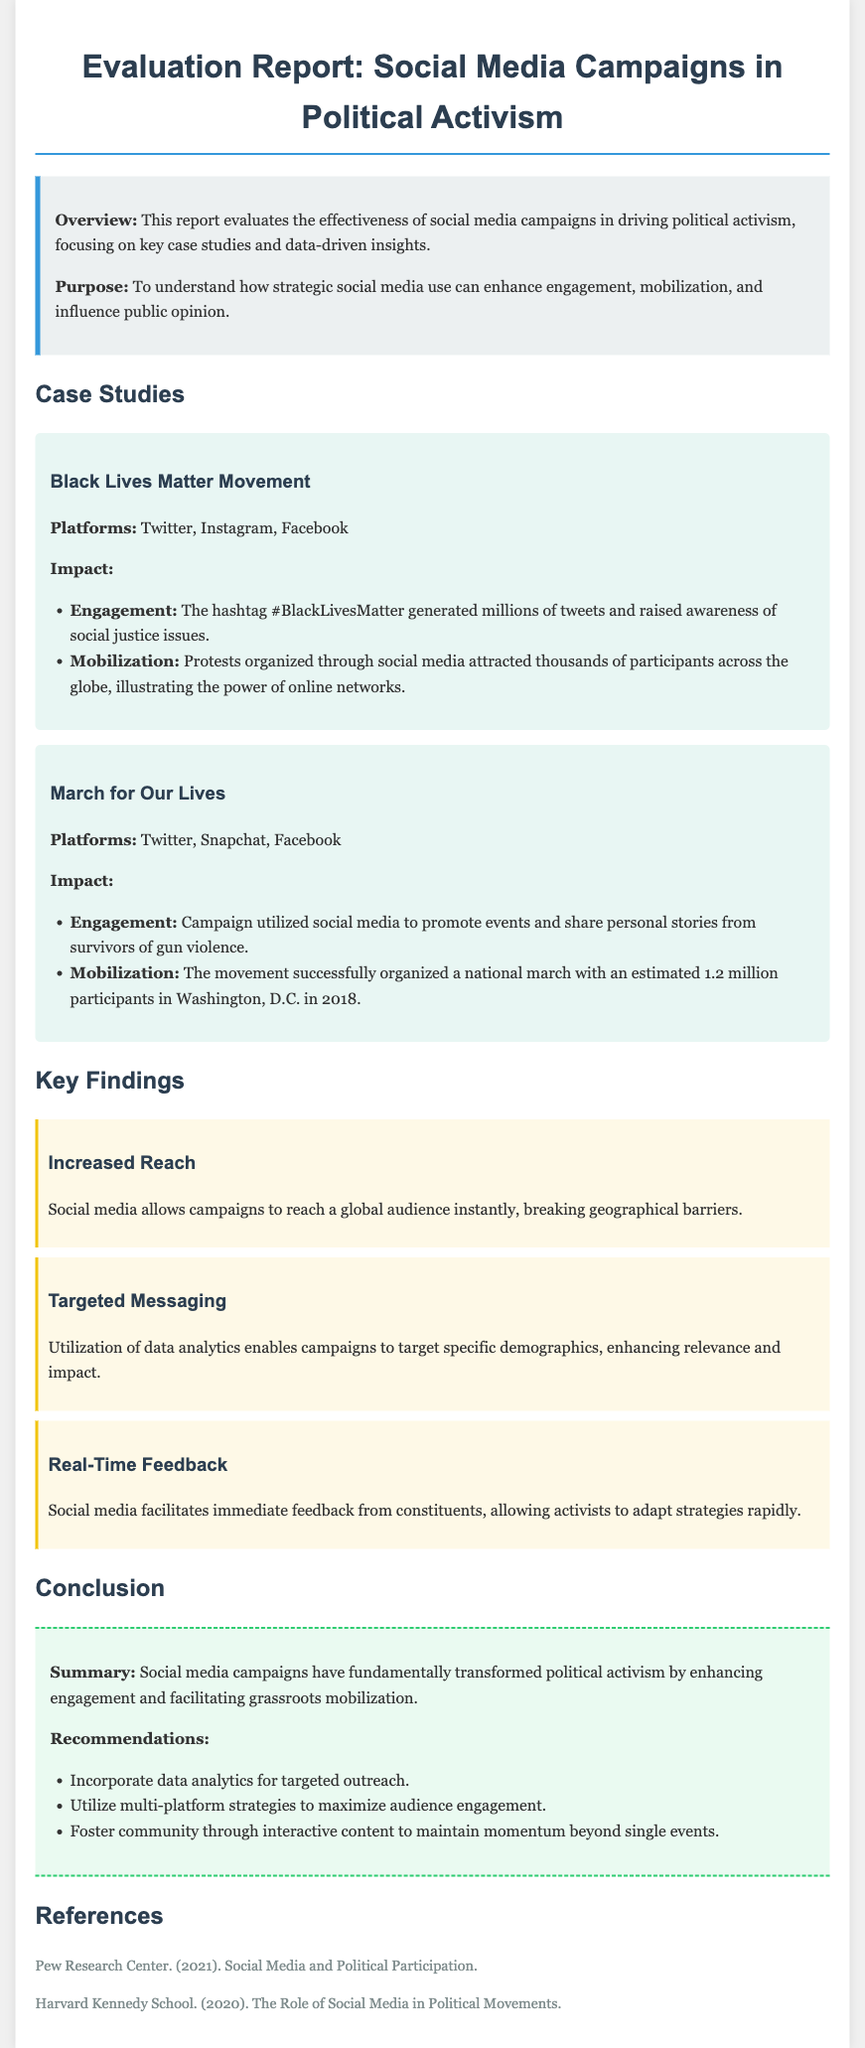What is the title of the report? The title of the report is presented at the top of the document, clearly stating its focus.
Answer: Evaluation Report: Social Media Campaigns in Political Activism What movement is associated with the hashtag #BlackLivesMatter? The document provides a specific case study that mentions this hashtag as part of its engagement impact.
Answer: Black Lives Matter Movement How many participants were estimated at the March for Our Lives event in 2018? The report mentions the estimated number of participants attending this significant event in the document.
Answer: 1.2 million What is one key finding related to audience reach? The document lists findings that exemplify the advantages of social media in political activism.
Answer: Increased Reach What recommendation is made regarding community engagement? Recommendations in the conclusion suggest ways for campaigns to maintain momentum through specific strategies.
Answer: Foster community through interactive content 